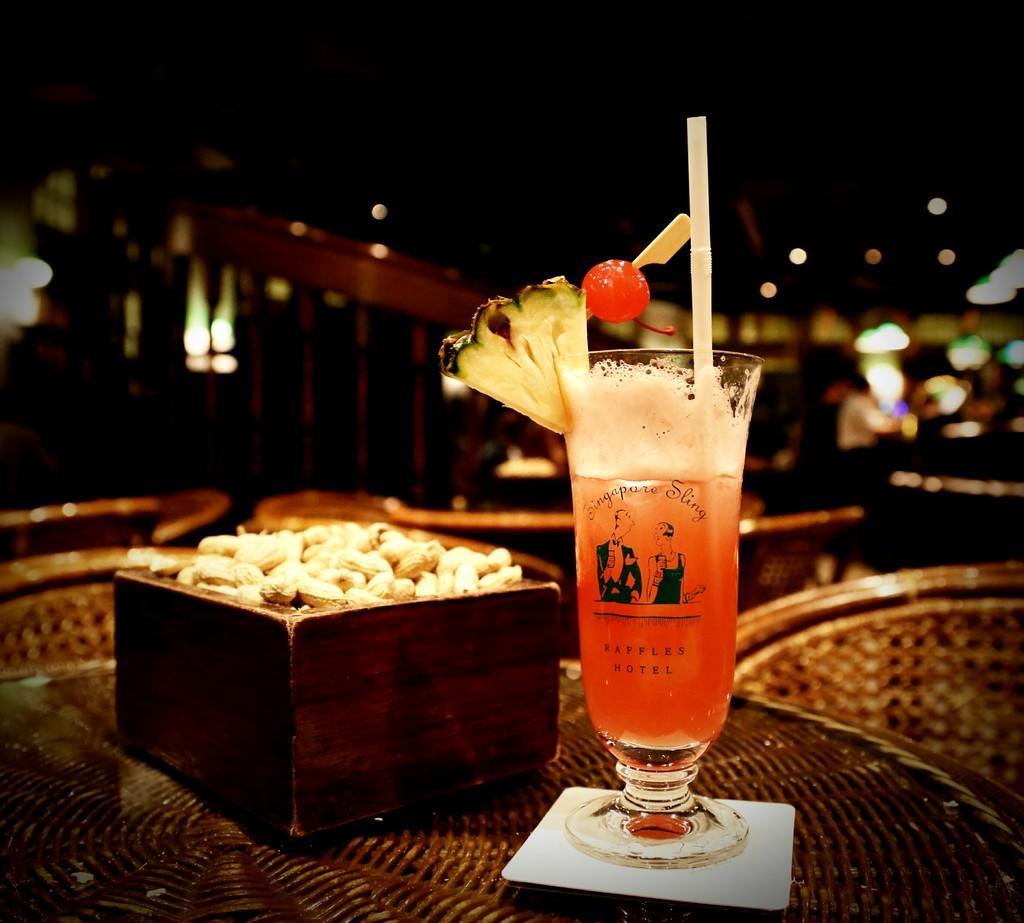Please provide a concise description of this image. In this picture we can see a glass with liquid, straw and fruits on an object. On the left side of the glass, there are peanuts in an object. Behind the glass, there are lights and the blurred background. 